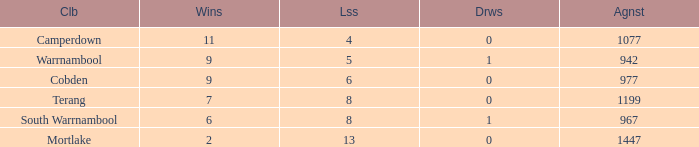How many draws did Mortlake have when the losses were more than 5? 1.0. 